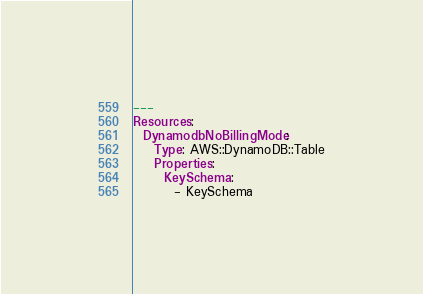<code> <loc_0><loc_0><loc_500><loc_500><_YAML_>---
Resources:
  DynamodbNoBillingMode:
    Type: AWS::DynamoDB::Table
    Properties: 
      KeySchema: 
        - KeySchema</code> 